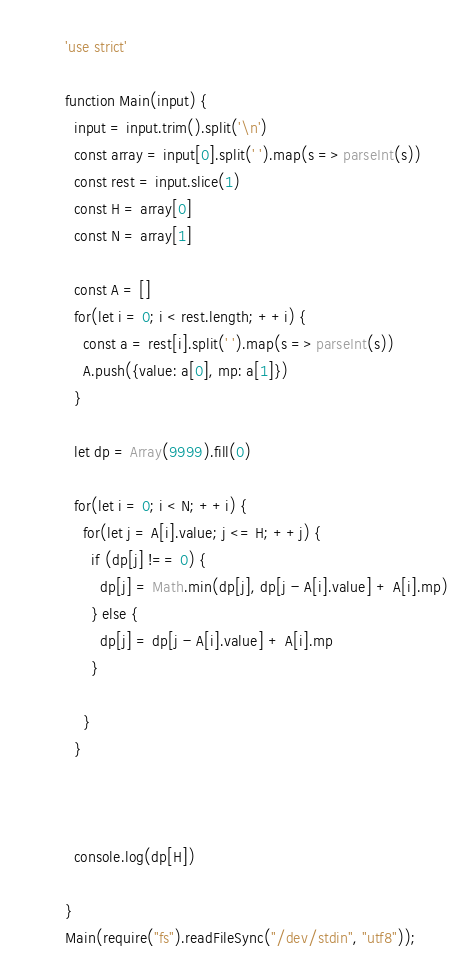Convert code to text. <code><loc_0><loc_0><loc_500><loc_500><_JavaScript_>'use strict'

function Main(input) {
  input = input.trim().split('\n')
  const array = input[0].split(' ').map(s => parseInt(s))
  const rest = input.slice(1)
  const H = array[0]
  const N = array[1]

  const A = []
  for(let i = 0; i < rest.length; ++i) {
    const a = rest[i].split(' ').map(s => parseInt(s))
    A.push({value: a[0], mp: a[1]})
  }

  let dp = Array(9999).fill(0)

  for(let i = 0; i < N; ++i) {
    for(let j = A[i].value; j <= H; ++j) {
      if (dp[j] !== 0) {
        dp[j] = Math.min(dp[j], dp[j - A[i].value] + A[i].mp)
      } else {
        dp[j] = dp[j - A[i].value] + A[i].mp
      }
      
    }
  }



  console.log(dp[H])
  
}
Main(require("fs").readFileSync("/dev/stdin", "utf8"));
</code> 